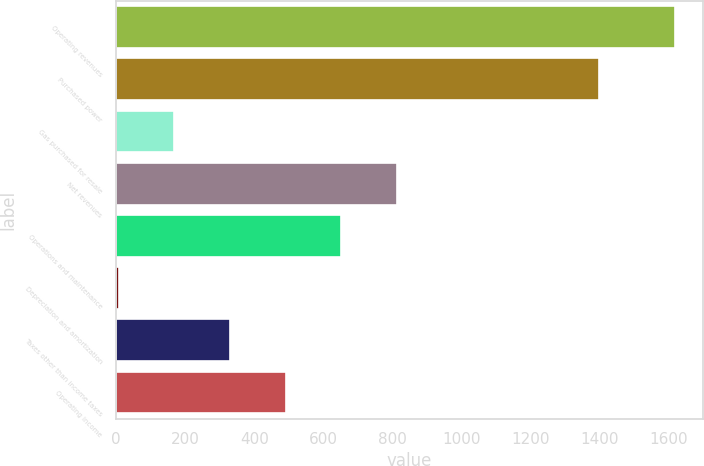Convert chart. <chart><loc_0><loc_0><loc_500><loc_500><bar_chart><fcel>Operating revenues<fcel>Purchased power<fcel>Gas purchased for resale<fcel>Net revenues<fcel>Operations and maintenance<fcel>Depreciation and amortization<fcel>Taxes other than income taxes<fcel>Operating income<nl><fcel>1617<fcel>1397<fcel>168<fcel>812<fcel>651<fcel>7<fcel>329<fcel>490<nl></chart> 